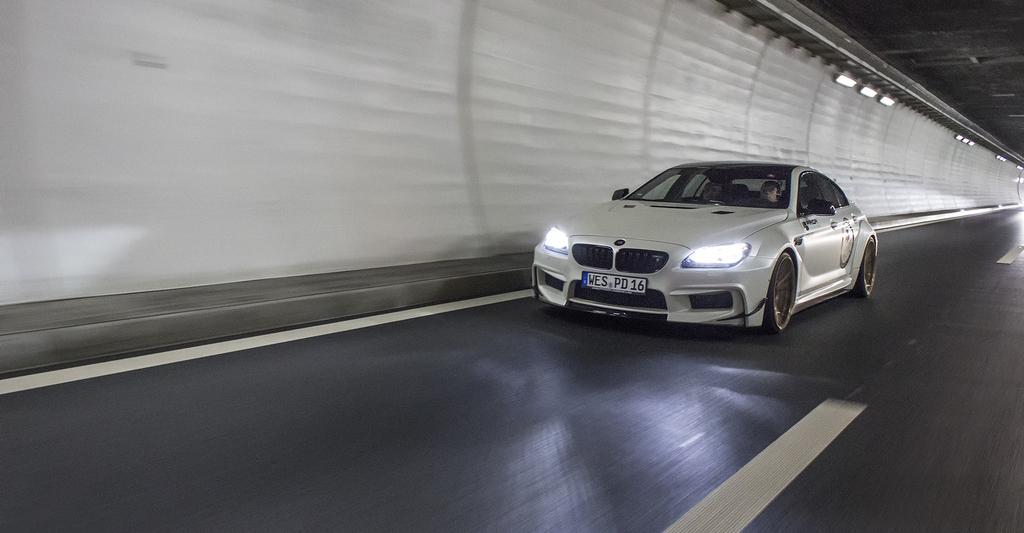Describe this image in one or two sentences. This image consists of a car in white color. At the bottom, there is a road. On the left, there is a wall along with lights. At the top, there is a roof. 